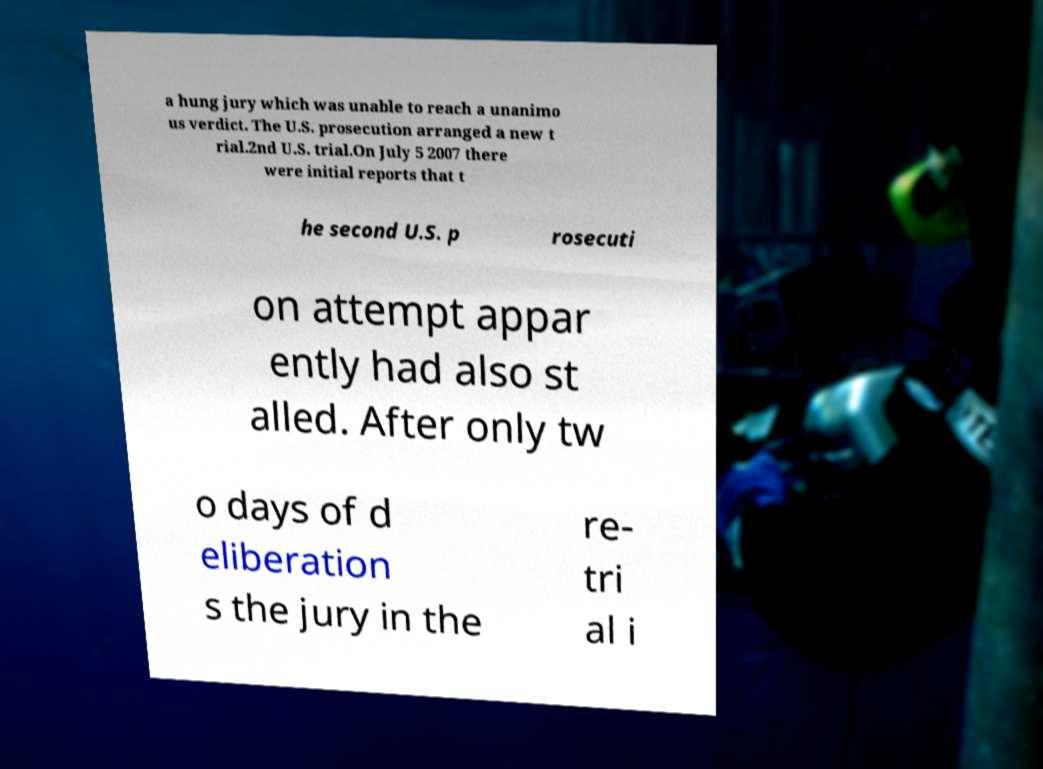Could you assist in decoding the text presented in this image and type it out clearly? a hung jury which was unable to reach a unanimo us verdict. The U.S. prosecution arranged a new t rial.2nd U.S. trial.On July 5 2007 there were initial reports that t he second U.S. p rosecuti on attempt appar ently had also st alled. After only tw o days of d eliberation s the jury in the re- tri al i 